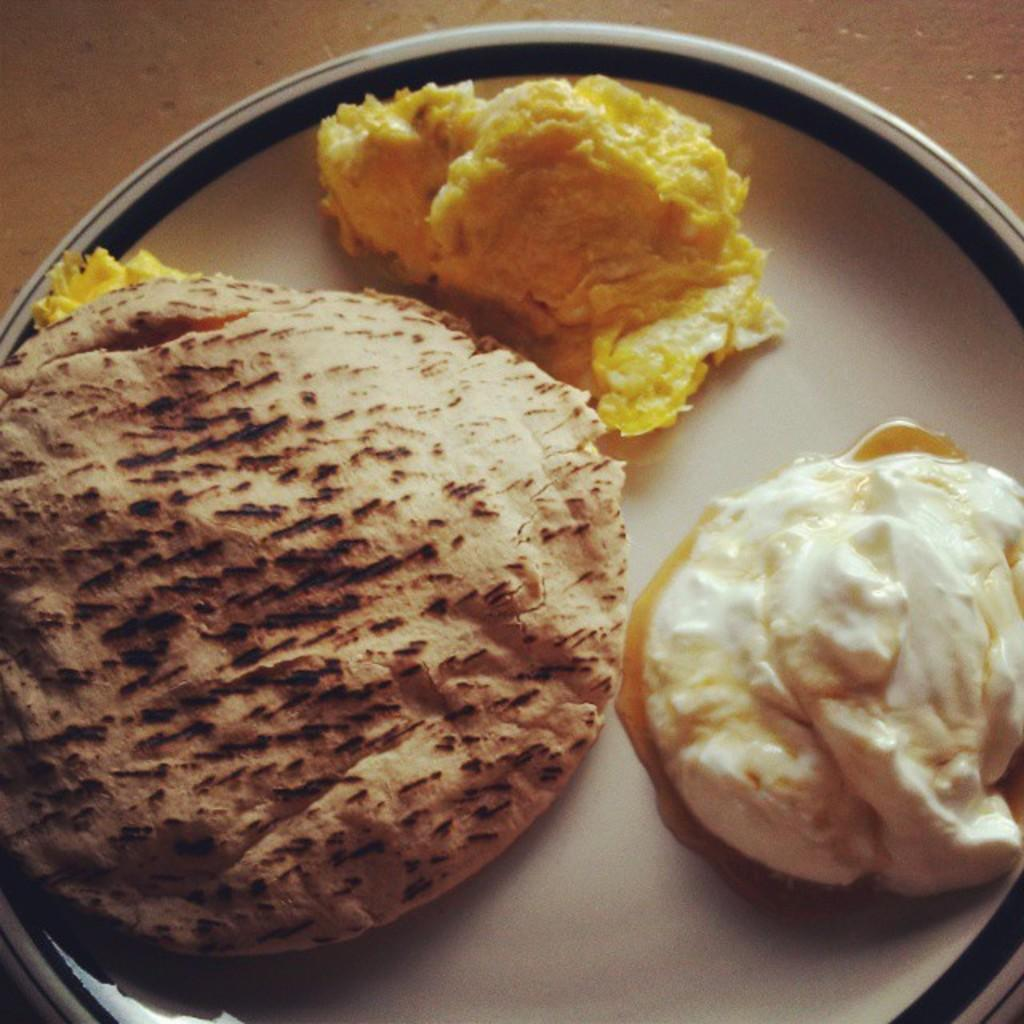What is present in the image related to food? There is food in the image, and it is kept in a plate. Can you describe the surface on which the plate is placed? The floor is visible in the image, and it is the surface on which the plate is placed. What type of polish is being applied to the goldfish in the image? There is no goldfish or polish present in the image; it only features food on a plate and a visible floor. 